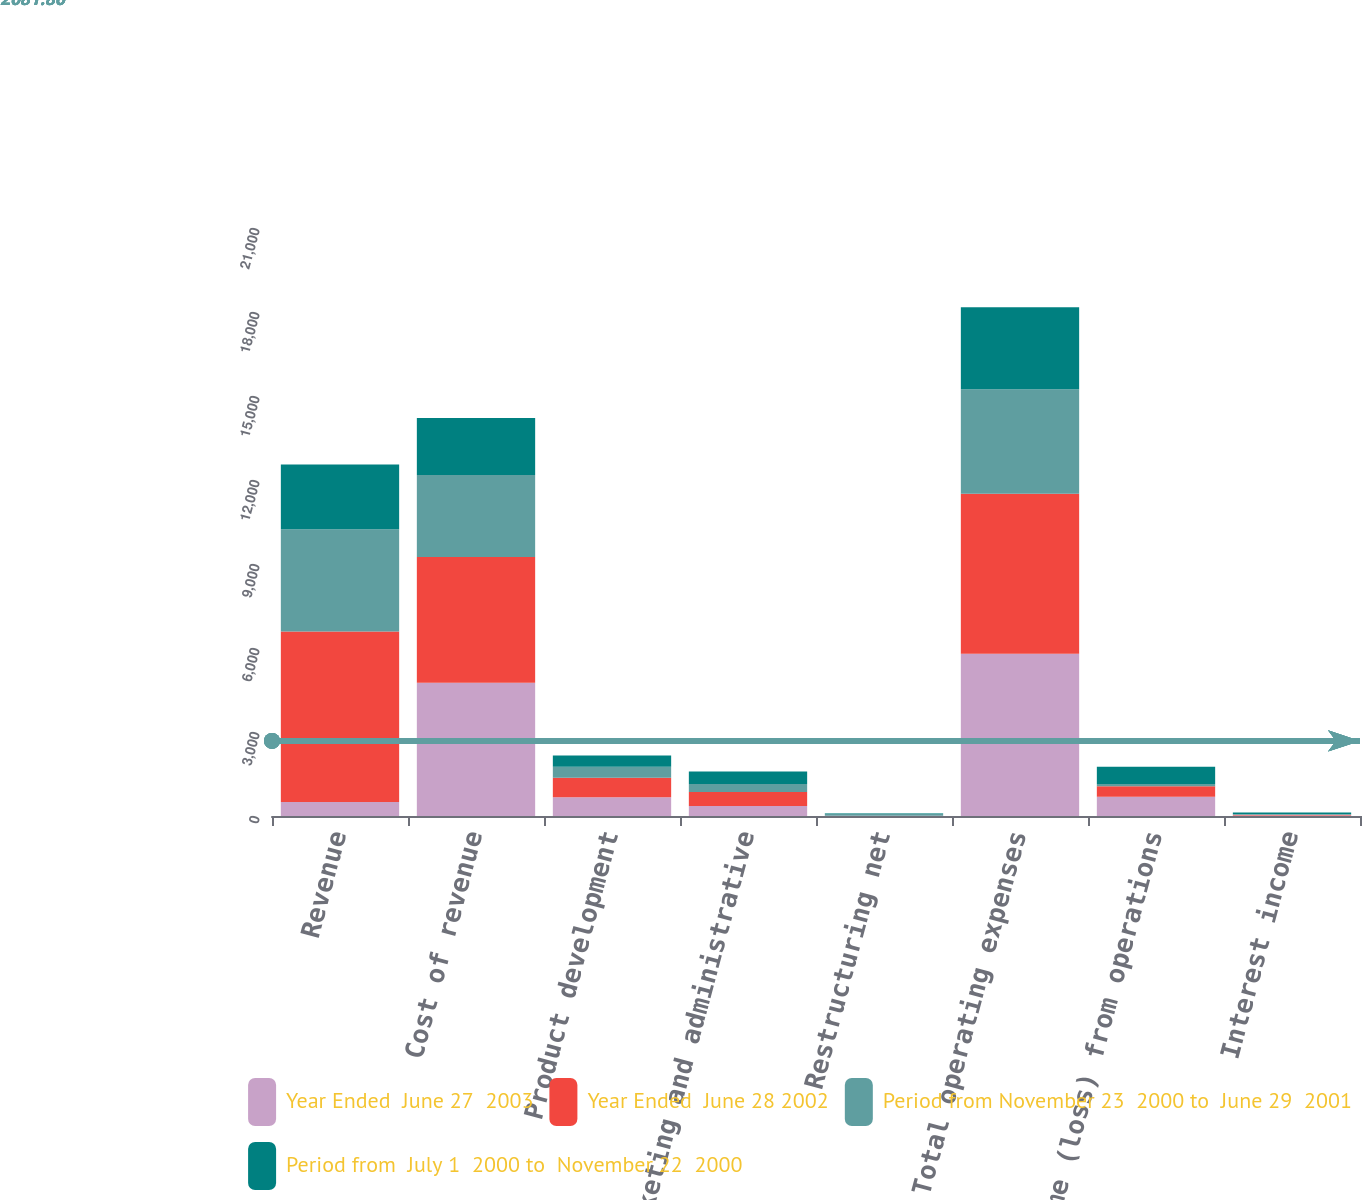Convert chart. <chart><loc_0><loc_0><loc_500><loc_500><stacked_bar_chart><ecel><fcel>Revenue<fcel>Cost of revenue<fcel>Product development<fcel>Marketing and administrative<fcel>Restructuring net<fcel>Total operating expenses<fcel>Income (loss) from operations<fcel>Interest income<nl><fcel>Year Ended  June 27  2003<fcel>498<fcel>4759<fcel>670<fcel>357<fcel>9<fcel>5795<fcel>691<fcel>16<nl><fcel>Year Ended  June 28 2002<fcel>6087<fcel>4494<fcel>698<fcel>498<fcel>4<fcel>5713<fcel>374<fcel>25<nl><fcel>Period from November 23  2000 to  June 29  2001<fcel>3656<fcel>2924<fcel>388<fcel>288<fcel>66<fcel>3730<fcel>74<fcel>31<nl><fcel>Period from  July 1  2000 to  November 22  2000<fcel>2310<fcel>2035<fcel>409<fcel>450<fcel>19<fcel>2933<fcel>623<fcel>57<nl></chart> 